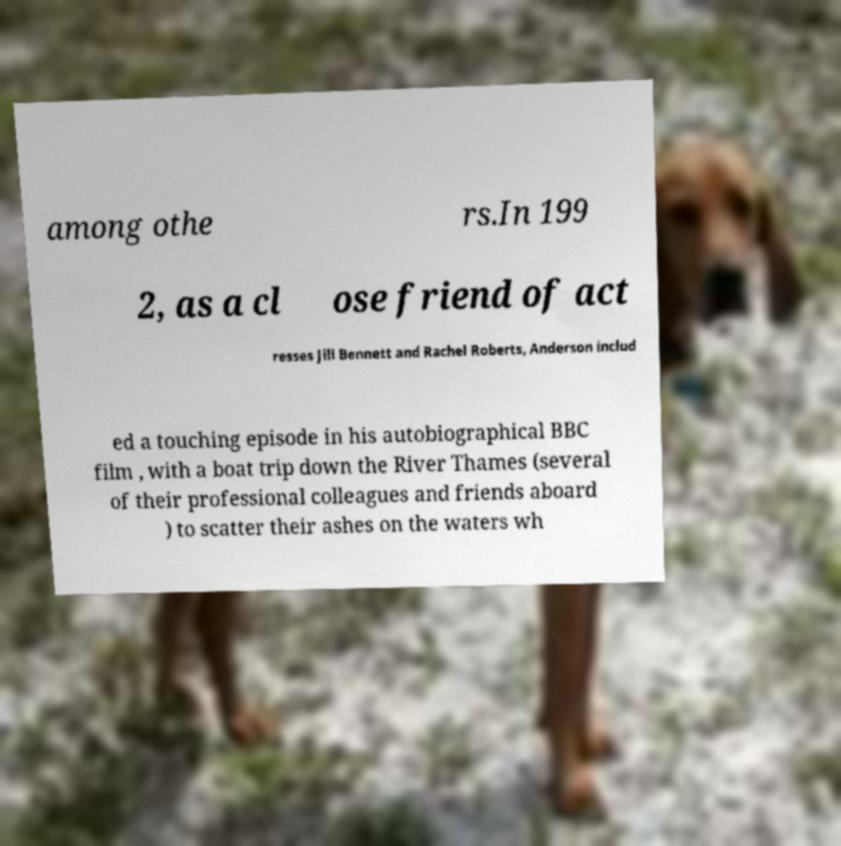For documentation purposes, I need the text within this image transcribed. Could you provide that? among othe rs.In 199 2, as a cl ose friend of act resses Jill Bennett and Rachel Roberts, Anderson includ ed a touching episode in his autobiographical BBC film , with a boat trip down the River Thames (several of their professional colleagues and friends aboard ) to scatter their ashes on the waters wh 